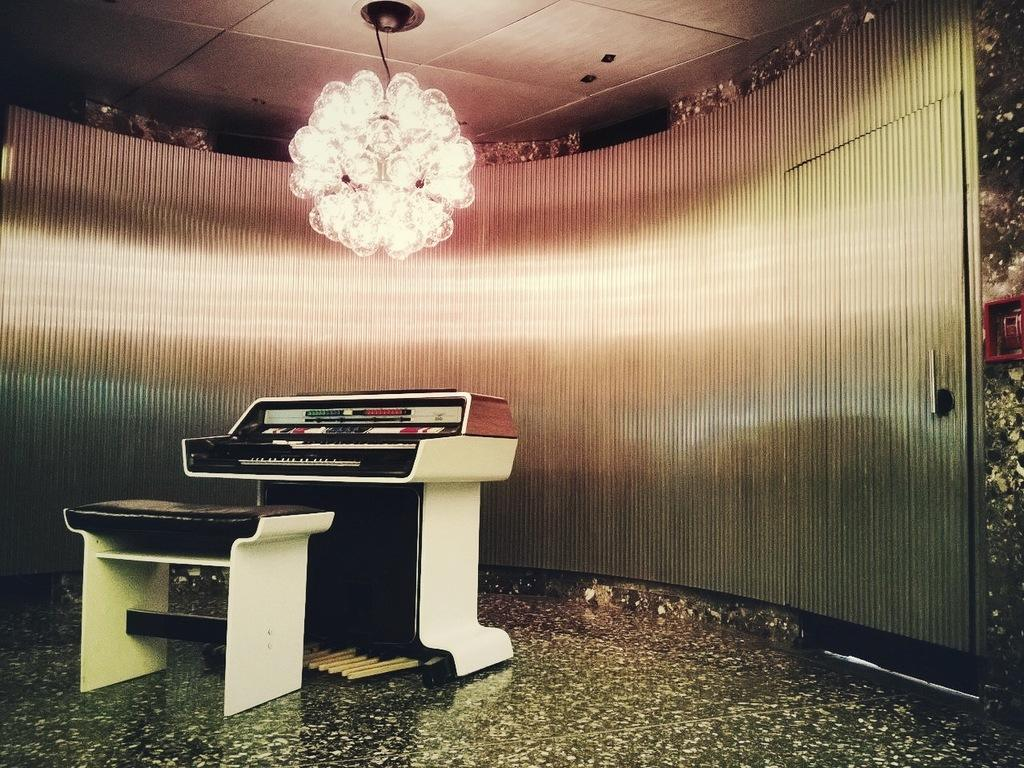What piece of furniture is on the floor in the image? There is a table on the floor in the image. What musical instrument can be seen in the image? There is a piano in the image. What type of architectural feature is present in the image? There is a wall in the image. What feature allows for passage between rooms in the image? There is a door in the image. What type of lighting fixture is present in the image? There is a chandelier in the image. How does the transport system work in the image? There is no transport system present in the image. Can you describe the cat sitting on the piano in the image? There is no cat present in the image. 